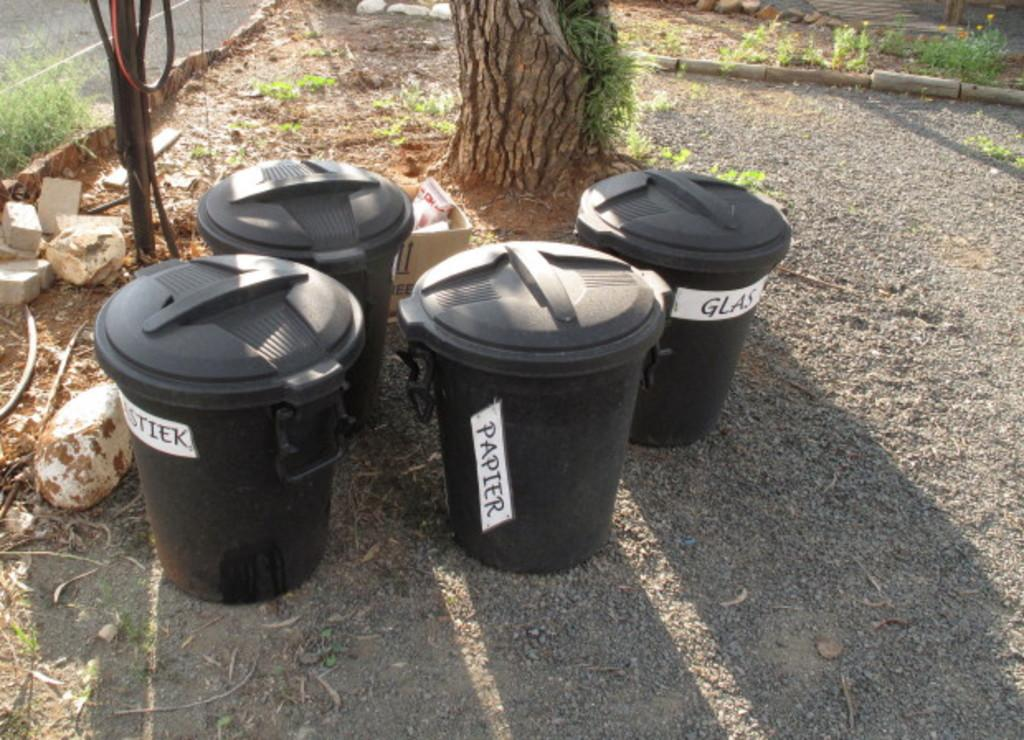<image>
Offer a succinct explanation of the picture presented. some black trash cans with names like Papier on them 